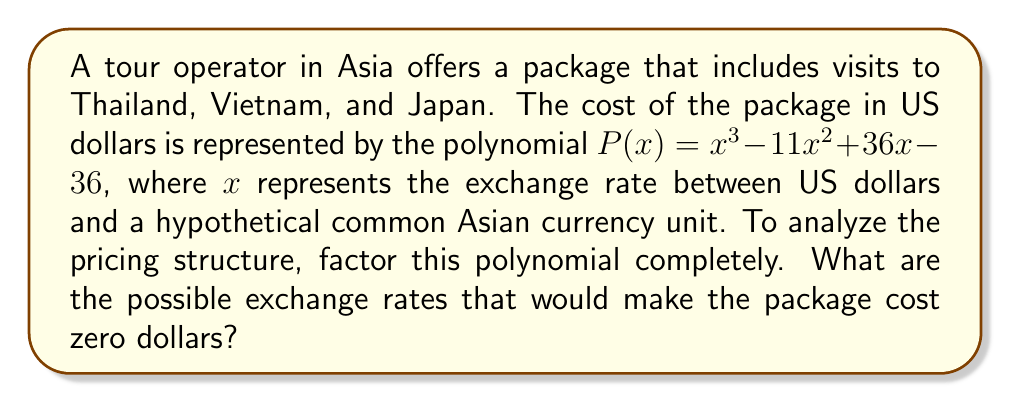Could you help me with this problem? To factor the polynomial $P(x) = x^3 - 11x^2 + 36x - 36$, we'll follow these steps:

1) First, let's check if there's a common factor. There isn't, so we proceed.

2) This is a cubic polynomial. Let's try to guess one root. Since the constant term is -36, possible factors are ±1, ±2, ±3, ±4, ±6, ±9, ±12, ±18, ±36.

3) Testing these, we find that $x = 3$ is a root (as $3^3 - 11(3^2) + 36(3) - 36 = 0$).

4) Now we can factor out $(x - 3)$:

   $P(x) = (x - 3)(x^2 - 8x + 12)$

5) The quadratic factor $x^2 - 8x + 12$ can be factored further:

   $x^2 - 8x + 12 = (x - 6)(x - 2)$

6) Therefore, the complete factorization is:

   $P(x) = (x - 3)(x - 6)(x - 2)$

The roots of this polynomial are the values of $x$ that make $P(x) = 0$, which are the factors we found: 3, 6, and 2.
Answer: The polynomial factors as $P(x) = (x - 3)(x - 6)(x - 2)$. The possible exchange rates that would make the package cost zero dollars are 3, 6, and 2 units of the hypothetical Asian currency per US dollar. 